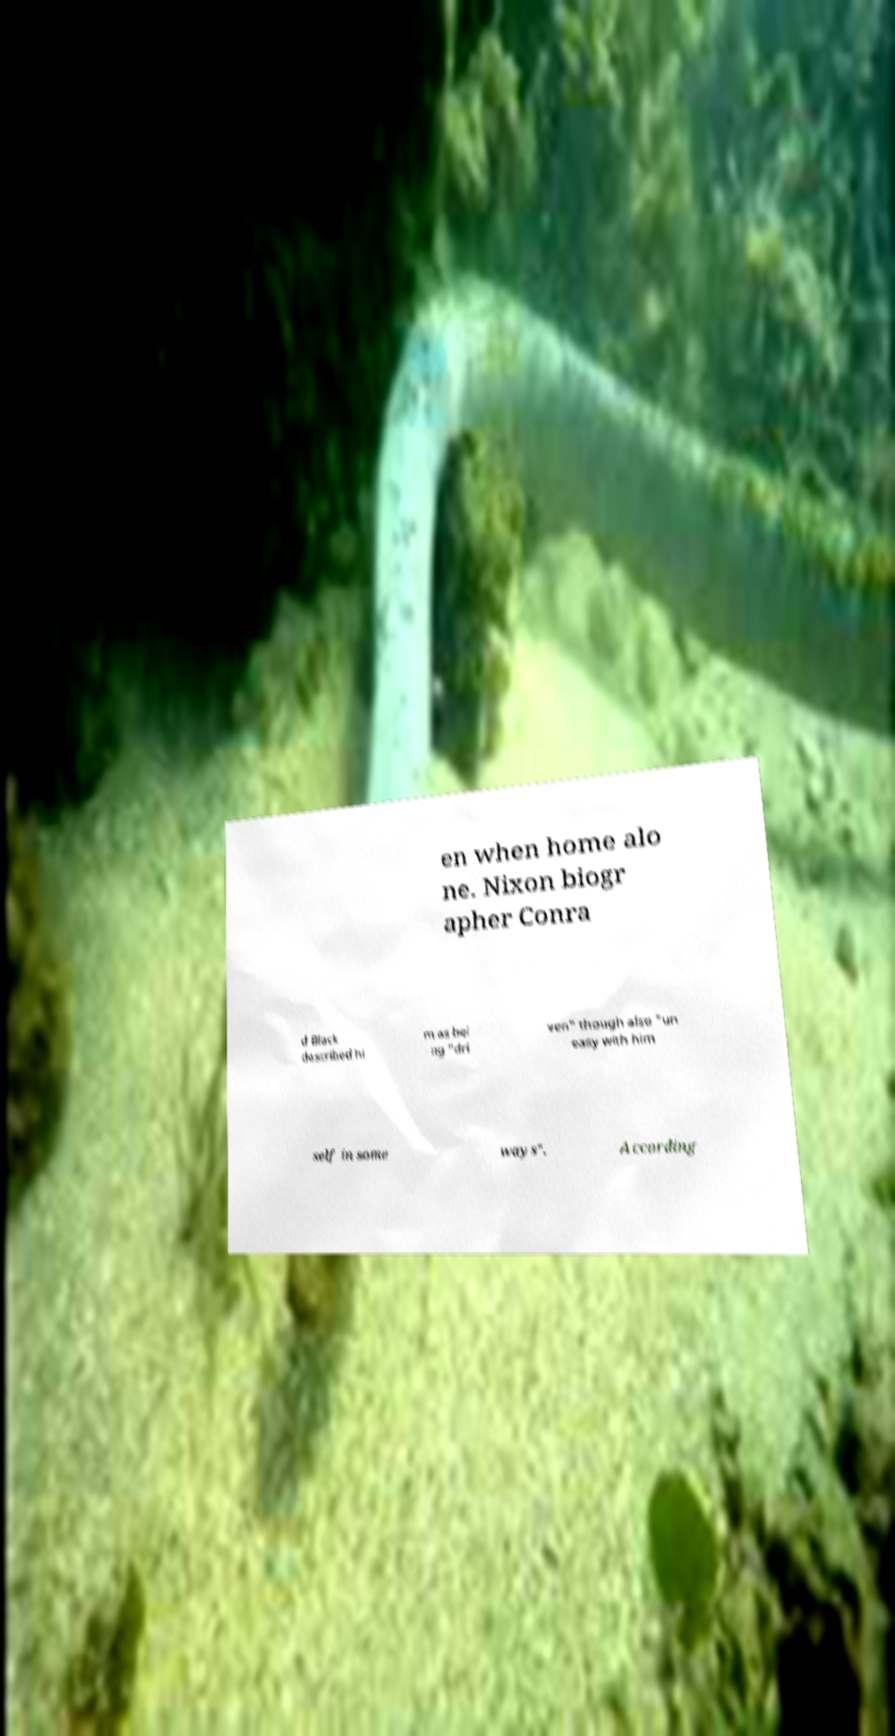I need the written content from this picture converted into text. Can you do that? en when home alo ne. Nixon biogr apher Conra d Black described hi m as bei ng "dri ven" though also "un easy with him self in some ways". According 